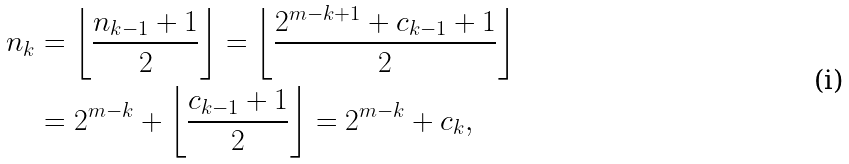<formula> <loc_0><loc_0><loc_500><loc_500>n _ { k } & = \left \lfloor \frac { n _ { k - 1 } + 1 } { 2 } \right \rfloor = \left \lfloor \frac { 2 ^ { m - k + 1 } + c _ { k - 1 } + 1 } { 2 } \right \rfloor \\ & = 2 ^ { m - k } + \left \lfloor \frac { c _ { k - 1 } + 1 } { 2 } \right \rfloor = 2 ^ { m - k } + c _ { k } ,</formula> 